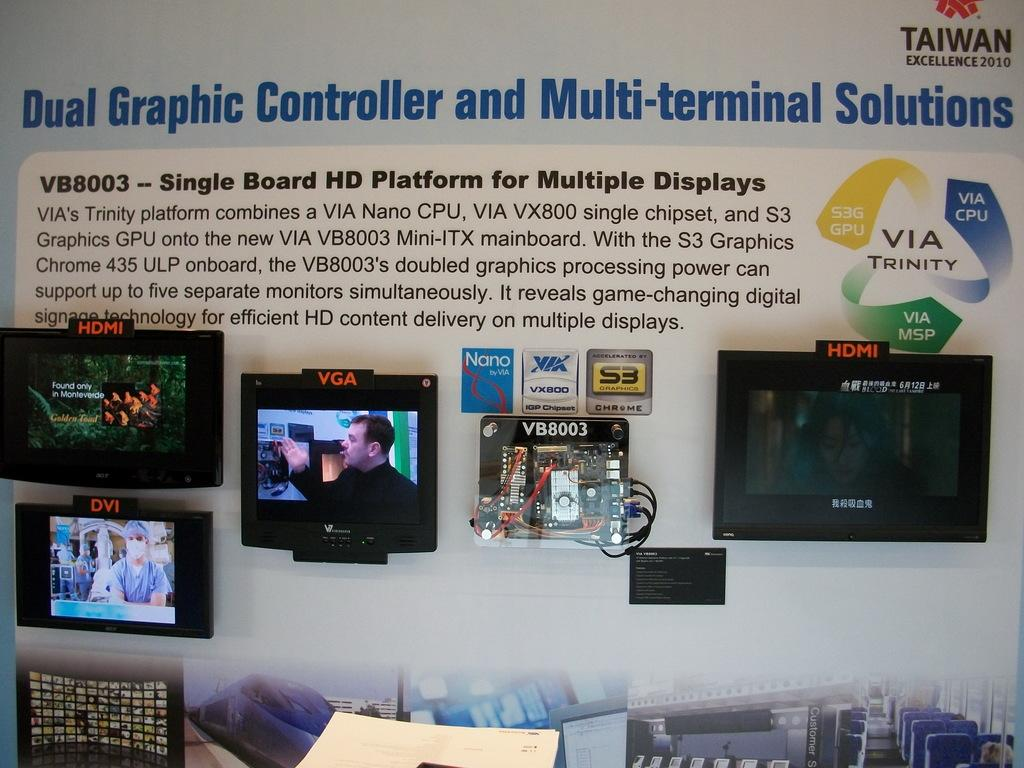<image>
Relay a brief, clear account of the picture shown. A display with information about dual graphic controllers has several monitors glued to it. 